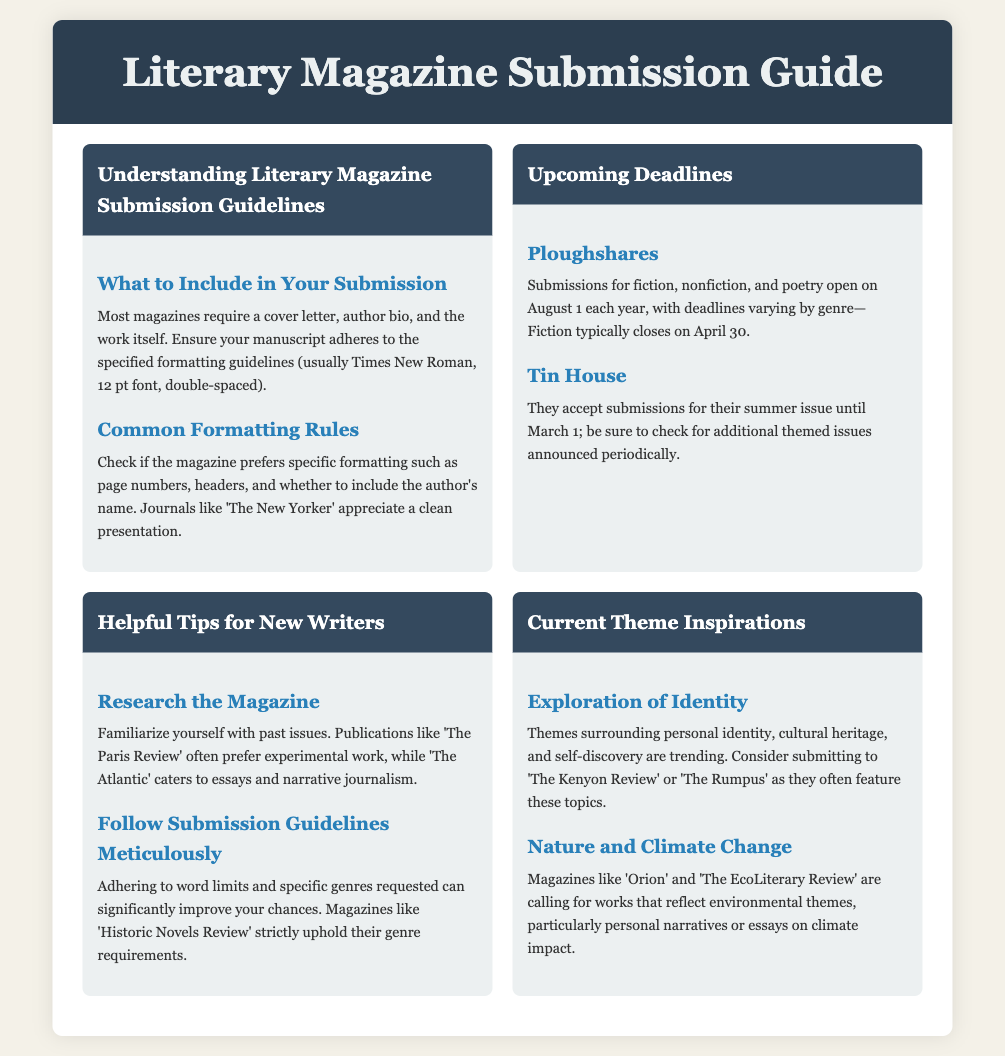What to include in your submission? The document lists required items for submissions including a cover letter, author bio, and the work itself along with formatting guidelines.
Answer: cover letter, author bio, manuscript When do Ploughshares submissions for fiction typically close? The document specifies the typical annual deadline for Ploughshares submissions for fiction.
Answer: April 30 What is the theme for submissions that is currently trending? The document mentions specific themes that are popular in submissions right now.
Answer: Exploration of Identity What formatting is commonly required? The document describes general formatting requirements that magazines expect from submissions.
Answer: Times New Roman, 12 pt font, double-spaced Which magazine prefers experimental work? The document indicates which publication has a tendency to favor a particular style of writing.
Answer: The Paris Review What is the deadline for Tin House's summer issue? The document provides information about the submission deadline for a specific magazine's issue.
Answer: March 1 What should new writers do to improve their chances? The document gives advice to new writers regarding a particular aspect of their submissions.
Answer: Research the Magazine Which magazines are calling for works reflecting environmental themes? The document identifies specific magazines that are seeking submissions on certain topics related to the environment.
Answer: Orion, The EcoLiterary Review 